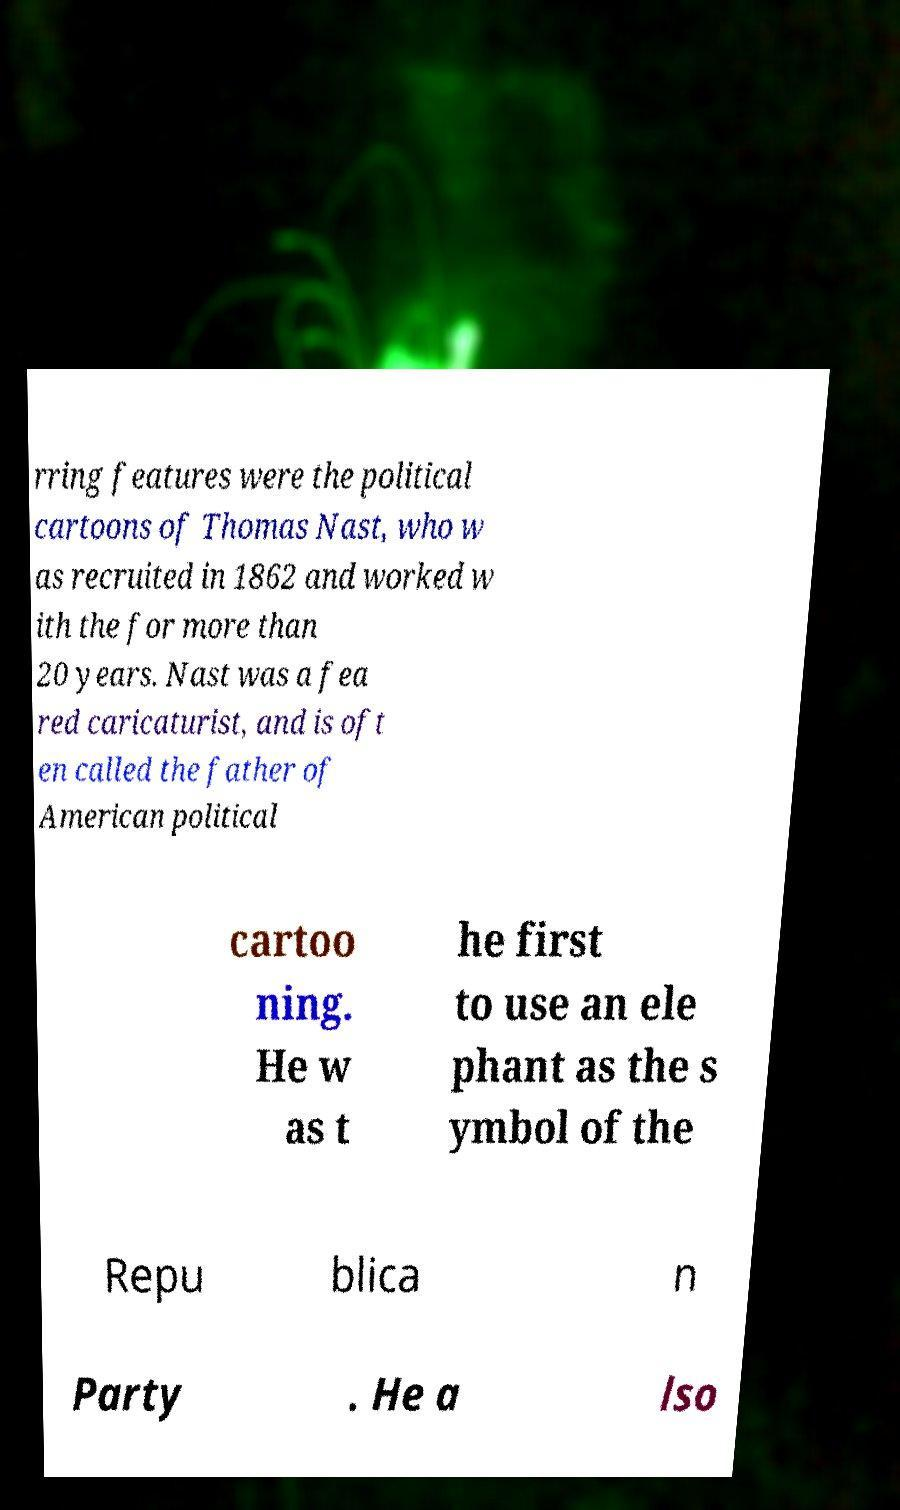I need the written content from this picture converted into text. Can you do that? rring features were the political cartoons of Thomas Nast, who w as recruited in 1862 and worked w ith the for more than 20 years. Nast was a fea red caricaturist, and is oft en called the father of American political cartoo ning. He w as t he first to use an ele phant as the s ymbol of the Repu blica n Party . He a lso 